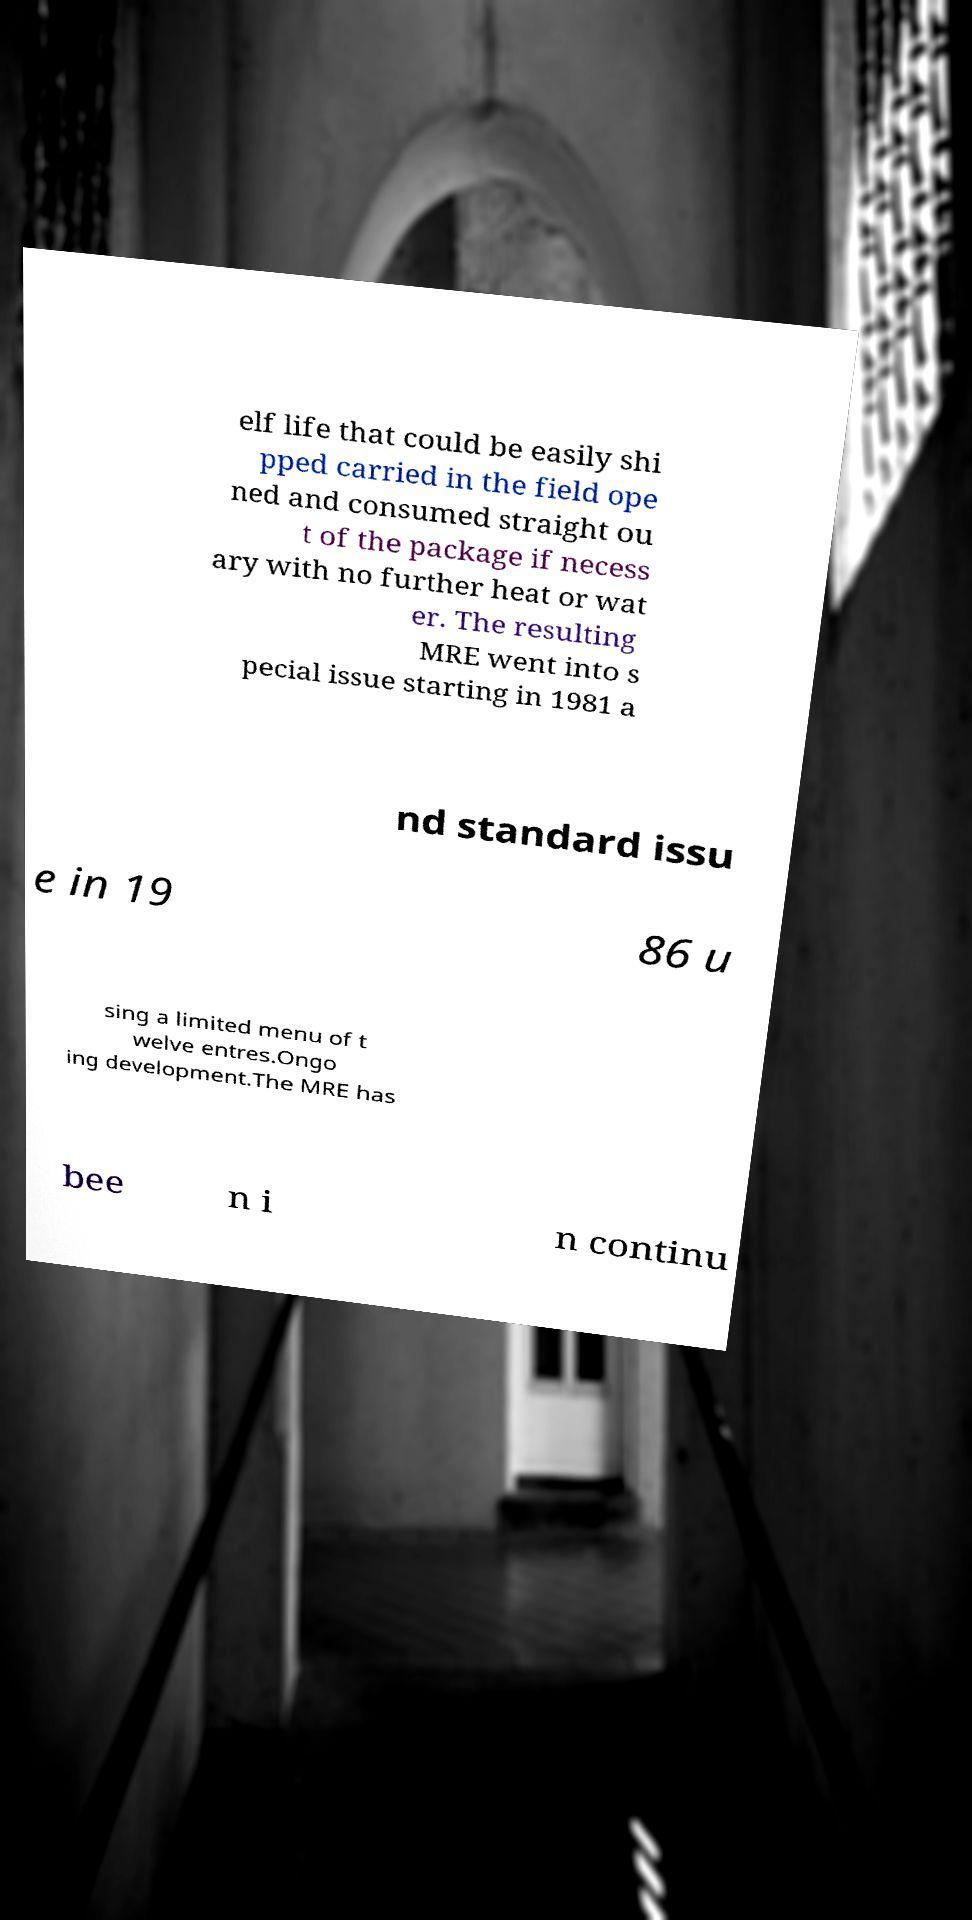Could you assist in decoding the text presented in this image and type it out clearly? elf life that could be easily shi pped carried in the field ope ned and consumed straight ou t of the package if necess ary with no further heat or wat er. The resulting MRE went into s pecial issue starting in 1981 a nd standard issu e in 19 86 u sing a limited menu of t welve entres.Ongo ing development.The MRE has bee n i n continu 